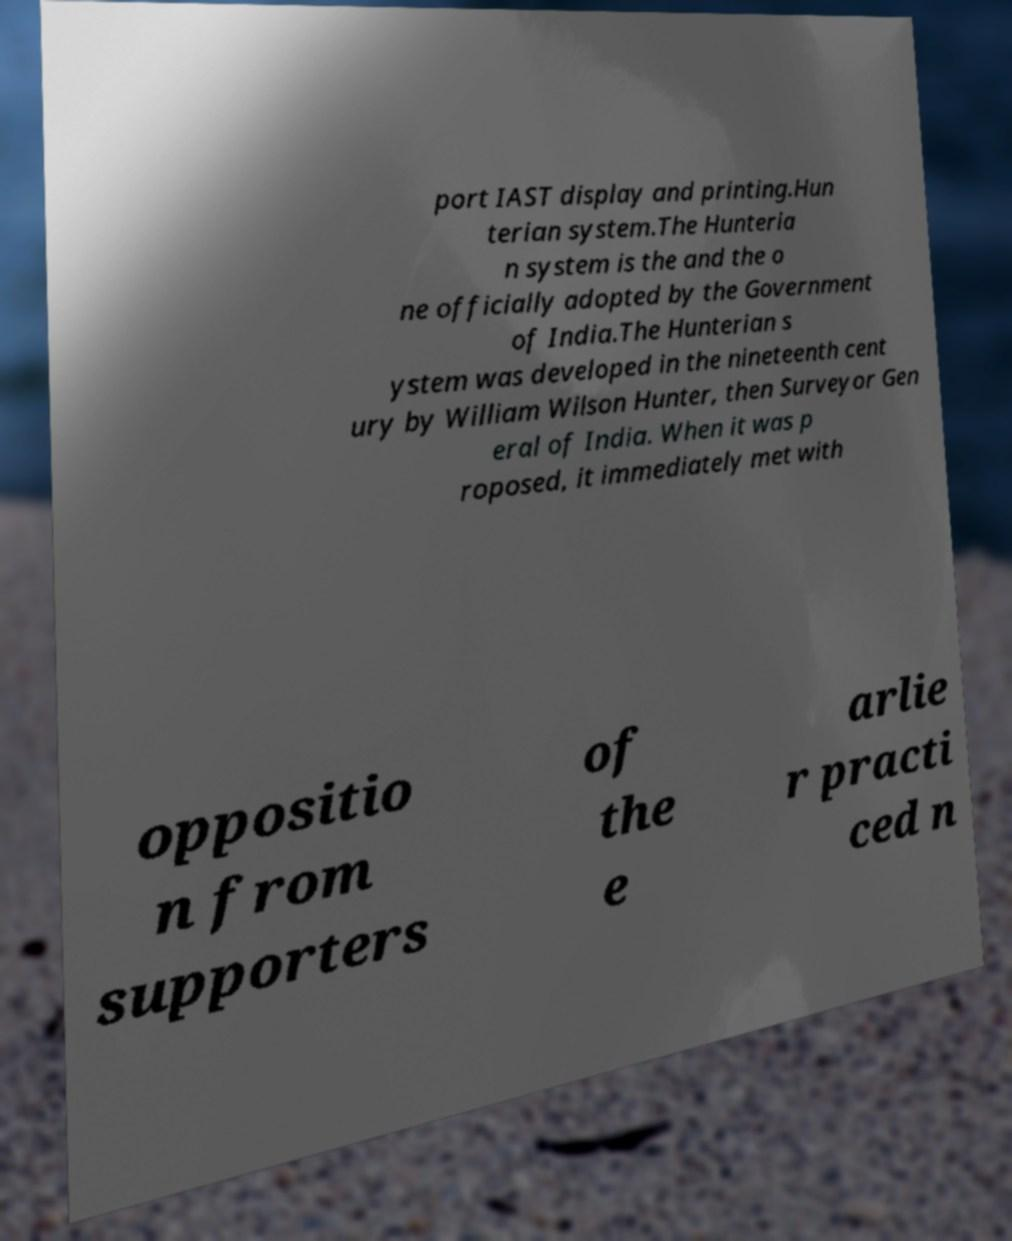Could you assist in decoding the text presented in this image and type it out clearly? port IAST display and printing.Hun terian system.The Hunteria n system is the and the o ne officially adopted by the Government of India.The Hunterian s ystem was developed in the nineteenth cent ury by William Wilson Hunter, then Surveyor Gen eral of India. When it was p roposed, it immediately met with oppositio n from supporters of the e arlie r practi ced n 